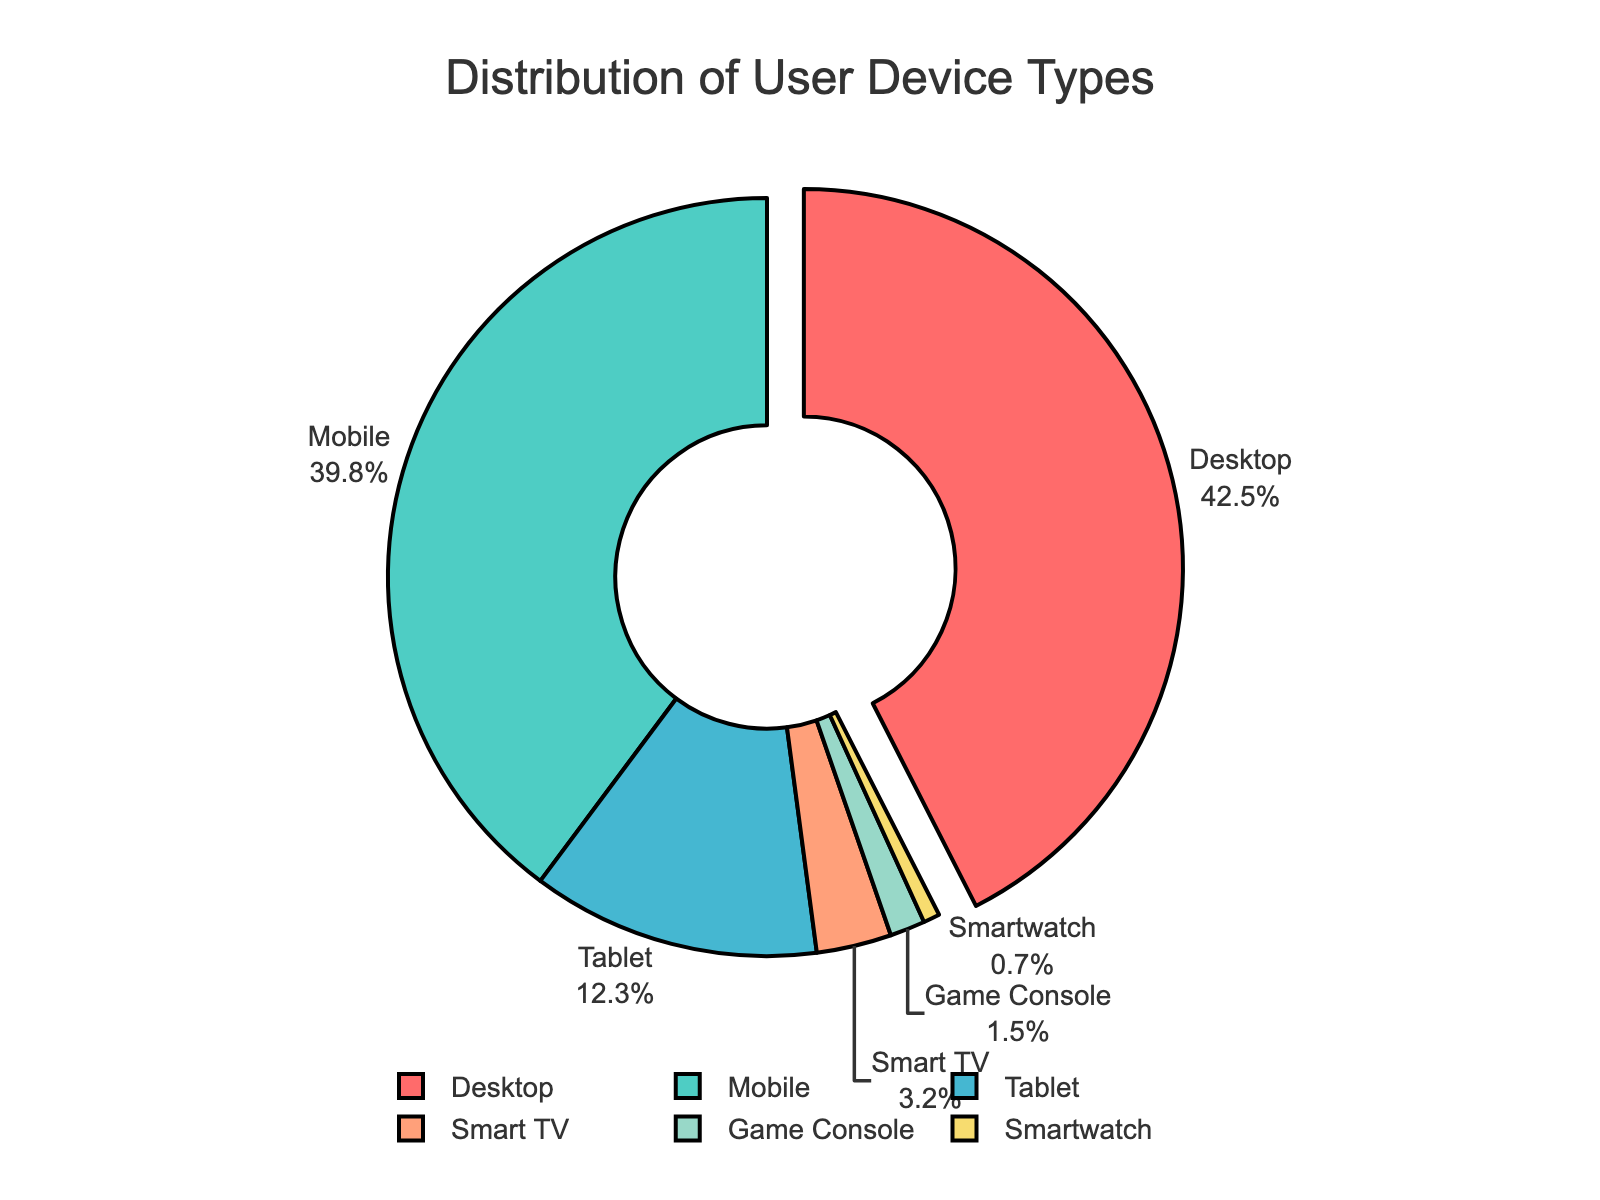What percentage of users access the website via mobile devices? The pie chart shows the distribution of user device types with percentages. Locate the segment labeled "Mobile" and read its corresponding percentage, which is 39.8%.
Answer: 39.8% How many device types have a usage percentage below 5%? Identify each section of the pie chart with percentages listed. There are four device types below 5%: Smart TV (3.2%), Game Console (1.5%), and Smartwatch (0.7%).
Answer: 3 Which device type has the highest percentage of users? Look at all the segments in the pie chart and locate the one with the highest percentage. The "Desktop" segment has the highest percentage at 42.5%.
Answer: Desktop What is the difference in user percentage between Desktop and Mobile? Identify the percentages for Desktop (42.5%) and Mobile (39.8%). Subtract the smaller percentage from the larger: 42.5% - 39.8% = 2.7%.
Answer: 2.7% What is the combined user percentage for Tablet and Smart TV? Find the percentages for Tablet (12.3%) and Smart TV (3.2%) and add them together: 12.3% + 3.2% = 15.5%.
Answer: 15.5% What portion of users access the website via either a Game Console or a Smartwatch? Identify the percentages for Game Console (1.5%) and Smartwatch (0.7%) and sum them: 1.5% + 0.7% = 2.2%.
Answer: 2.2% Which device type uses a turquoise color in the chart? The pie chart uses distinct colors for each segment. Turquoise is usually associated with the color representing "Mobile."
Answer: Mobile Is the percentage of Tablet users greater than the percentage of Game Console users? Compare the percentages for Tablet (12.3%) and Game Console (1.5%). 12.3% is greater than 1.5%.
Answer: Yes 